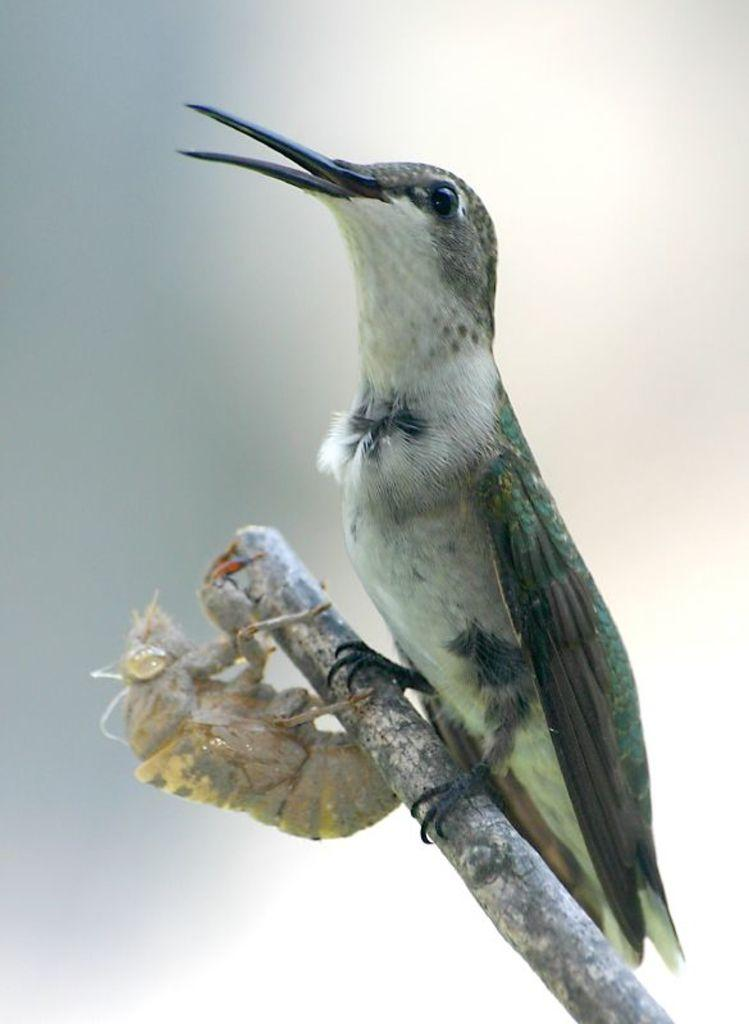What type of animal can be seen in the image? There is a bird in the image. What other creature is present in the image? There is an insect in the image. Where are the bird and insect located in the image? Both the bird and insect are on a stick. What type of cap is the police officer wearing in the image? There is no police officer or cap present in the image; it features a bird and an insect on a stick. What type of bun is the bird holding in the image? There is no bun present in the image; the bird is simply perched on a stick. 